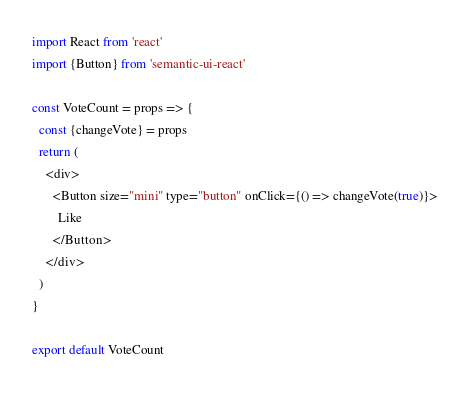<code> <loc_0><loc_0><loc_500><loc_500><_JavaScript_>import React from 'react'
import {Button} from 'semantic-ui-react'

const VoteCount = props => {
  const {changeVote} = props
  return (
    <div>
      <Button size="mini" type="button" onClick={() => changeVote(true)}>
        Like
      </Button>
    </div>
  )
}

export default VoteCount
</code> 